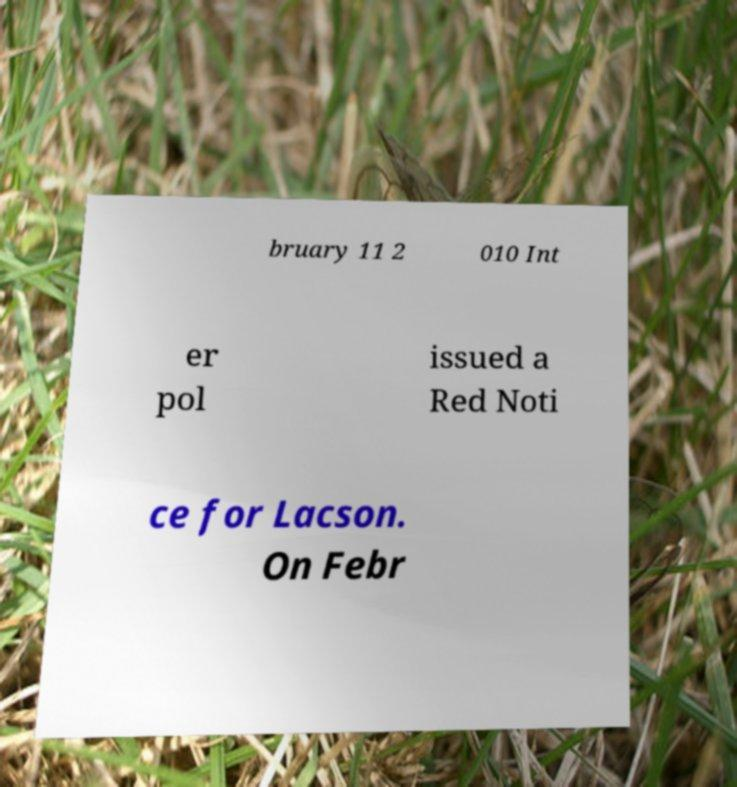For documentation purposes, I need the text within this image transcribed. Could you provide that? bruary 11 2 010 Int er pol issued a Red Noti ce for Lacson. On Febr 